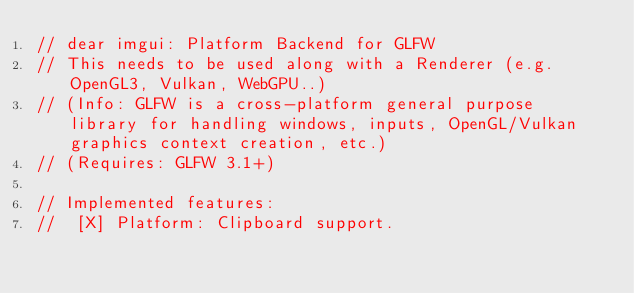<code> <loc_0><loc_0><loc_500><loc_500><_C++_>// dear imgui: Platform Backend for GLFW
// This needs to be used along with a Renderer (e.g. OpenGL3, Vulkan, WebGPU..)
// (Info: GLFW is a cross-platform general purpose library for handling windows, inputs, OpenGL/Vulkan graphics context creation, etc.)
// (Requires: GLFW 3.1+)

// Implemented features:
//  [X] Platform: Clipboard support.</code> 